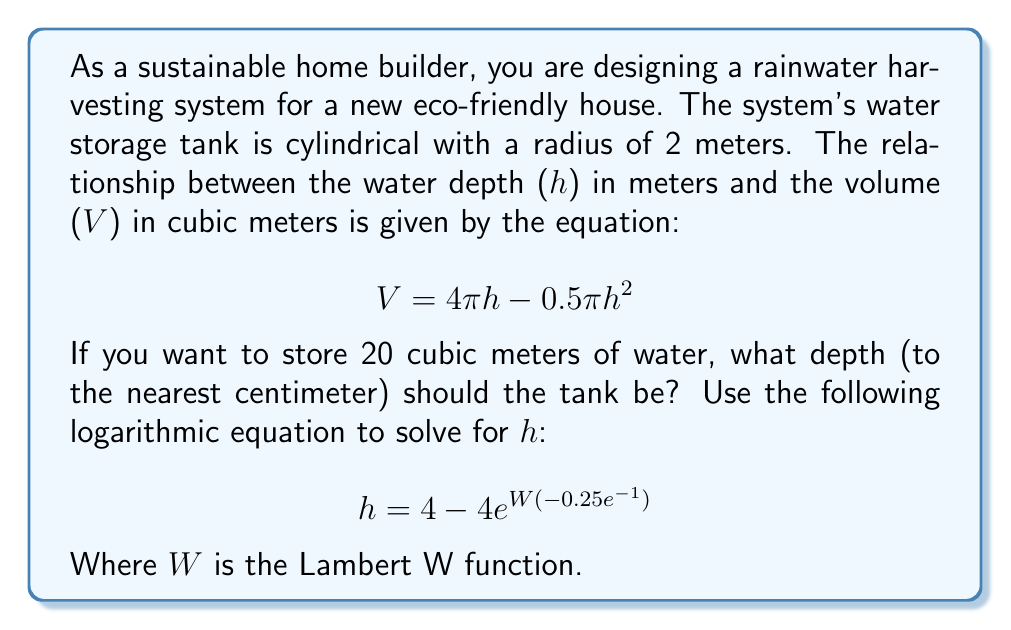Solve this math problem. To solve this problem, we'll follow these steps:

1) First, we need to understand that the given equation relates the volume (V) to the height (h) of the water in the tank:

   $$ V = 4\pi h - 0.5\pi h^2 $$

2) We're given that V = 20 m³, so we substitute this into the equation:

   $$ 20 = 4\pi h - 0.5\pi h^2 $$

3) This is a quadratic equation in h, which can be difficult to solve directly. Fortunately, we're given a logarithmic equation that solves this problem:

   $$ h = 4 - 4e^{W(-0.25e^{-1})} $$

4) The Lambert W function, denoted as W(x), is the inverse function of f(x) = xe^x. It's a special function used in various branches of mathematics.

5) In this case, we need to calculate W(-0.25e^(-1)). This can be done using a scientific calculator or a computer algebra system.

6) Using a calculator or computer, we find that:

   $$ W(-0.25e^{-1}) \approx -0.357402956 $$

7) Now we can substitute this value into our equation:

   $$ h = 4 - 4e^{-0.357402956} $$

8) Calculating this:

   $$ h \approx 4 - 4(0.699324481) $$
   $$ h \approx 4 - 2.797297924 $$
   $$ h \approx 1.202702076 $$

9) Rounding to the nearest centimeter:

   $$ h \approx 1.20 \text{ m} $$

Thus, the tank should be 1.20 meters deep to store 20 cubic meters of water.
Answer: The tank should be 1.20 meters deep. 